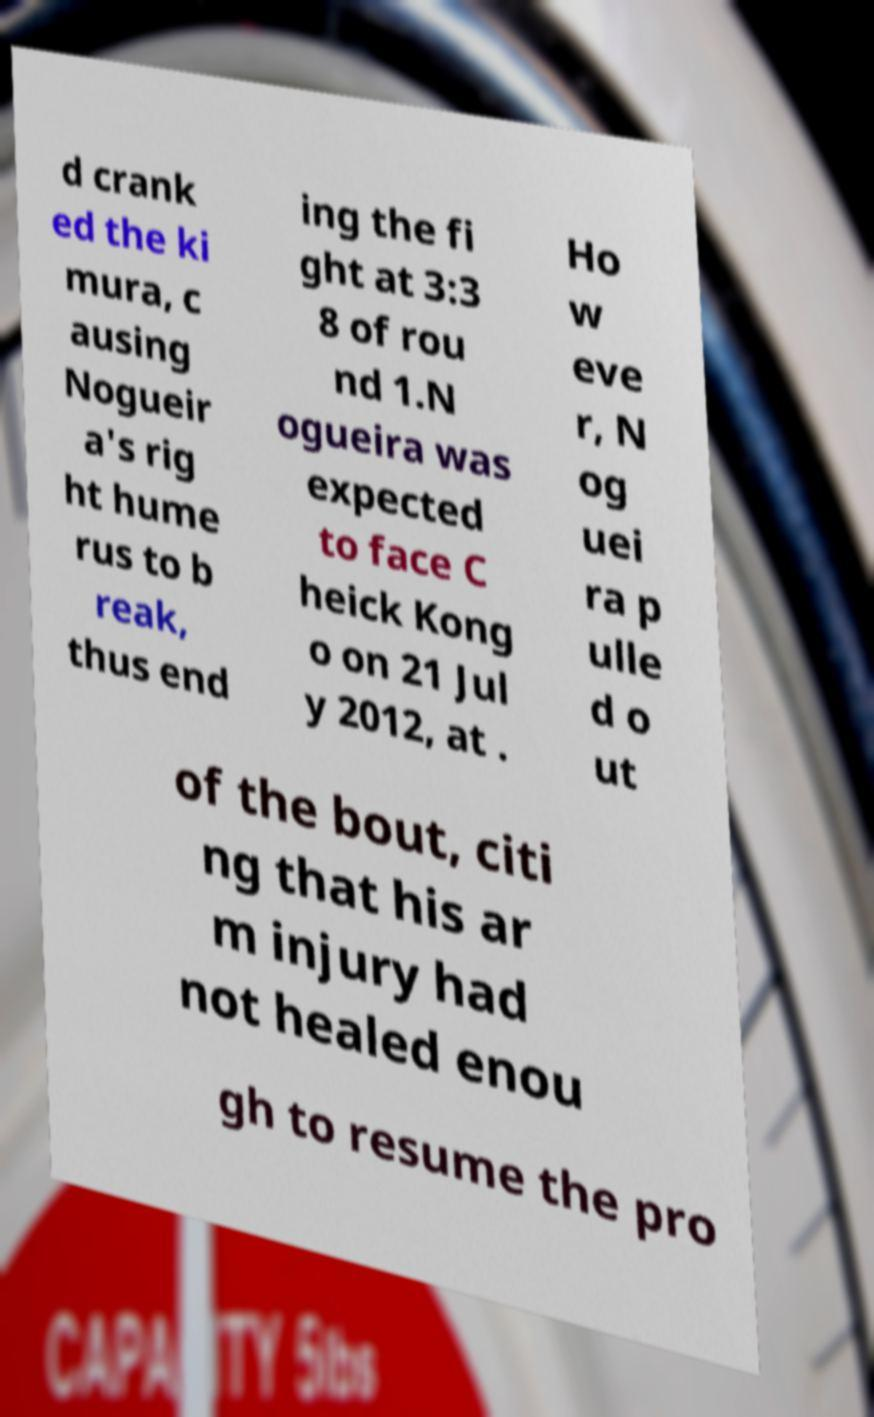Could you extract and type out the text from this image? d crank ed the ki mura, c ausing Nogueir a's rig ht hume rus to b reak, thus end ing the fi ght at 3:3 8 of rou nd 1.N ogueira was expected to face C heick Kong o on 21 Jul y 2012, at . Ho w eve r, N og uei ra p ulle d o ut of the bout, citi ng that his ar m injury had not healed enou gh to resume the pro 